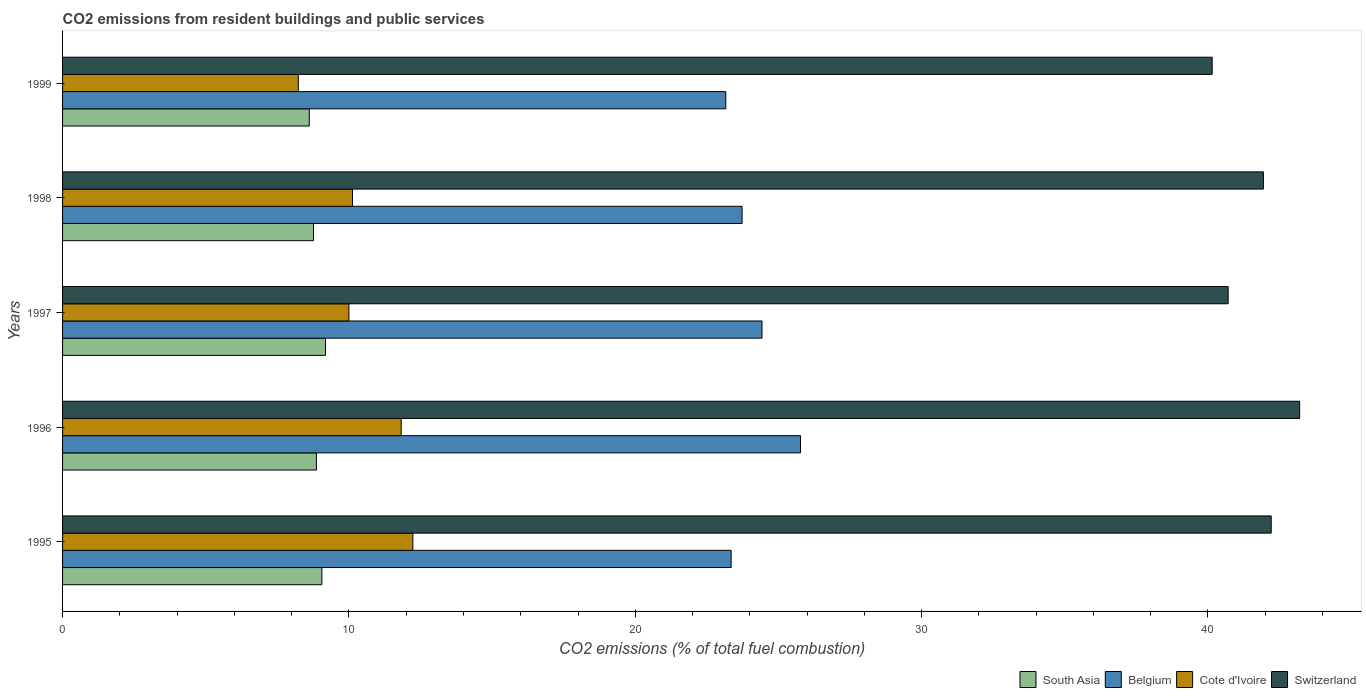How many different coloured bars are there?
Offer a terse response. 4. How many bars are there on the 1st tick from the bottom?
Your answer should be compact. 4. What is the label of the 2nd group of bars from the top?
Your answer should be very brief. 1998. In how many cases, is the number of bars for a given year not equal to the number of legend labels?
Give a very brief answer. 0. What is the total CO2 emitted in Cote d'Ivoire in 1995?
Your answer should be compact. 12.23. Across all years, what is the maximum total CO2 emitted in South Asia?
Your answer should be compact. 9.18. Across all years, what is the minimum total CO2 emitted in South Asia?
Ensure brevity in your answer.  8.62. In which year was the total CO2 emitted in Cote d'Ivoire maximum?
Offer a terse response. 1995. What is the total total CO2 emitted in Belgium in the graph?
Provide a succinct answer. 120.44. What is the difference between the total CO2 emitted in Switzerland in 1995 and that in 1997?
Your response must be concise. 1.5. What is the difference between the total CO2 emitted in South Asia in 1997 and the total CO2 emitted in Cote d'Ivoire in 1999?
Ensure brevity in your answer.  0.95. What is the average total CO2 emitted in Cote d'Ivoire per year?
Your answer should be compact. 10.48. In the year 1998, what is the difference between the total CO2 emitted in Switzerland and total CO2 emitted in Belgium?
Provide a short and direct response. 18.21. In how many years, is the total CO2 emitted in Switzerland greater than 38 ?
Ensure brevity in your answer.  5. What is the ratio of the total CO2 emitted in Switzerland in 1998 to that in 1999?
Your response must be concise. 1.04. Is the difference between the total CO2 emitted in Switzerland in 1998 and 1999 greater than the difference between the total CO2 emitted in Belgium in 1998 and 1999?
Offer a terse response. Yes. What is the difference between the highest and the second highest total CO2 emitted in Belgium?
Your answer should be compact. 1.35. What is the difference between the highest and the lowest total CO2 emitted in Switzerland?
Provide a succinct answer. 3.05. Is the sum of the total CO2 emitted in Switzerland in 1995 and 1999 greater than the maximum total CO2 emitted in Cote d'Ivoire across all years?
Your answer should be very brief. Yes. Is it the case that in every year, the sum of the total CO2 emitted in Belgium and total CO2 emitted in South Asia is greater than the sum of total CO2 emitted in Switzerland and total CO2 emitted in Cote d'Ivoire?
Give a very brief answer. No. What does the 1st bar from the bottom in 1998 represents?
Your response must be concise. South Asia. How many bars are there?
Offer a very short reply. 20. Are all the bars in the graph horizontal?
Give a very brief answer. Yes. How many legend labels are there?
Ensure brevity in your answer.  4. What is the title of the graph?
Keep it short and to the point. CO2 emissions from resident buildings and public services. Does "European Union" appear as one of the legend labels in the graph?
Make the answer very short. No. What is the label or title of the X-axis?
Keep it short and to the point. CO2 emissions (% of total fuel combustion). What is the label or title of the Y-axis?
Your answer should be very brief. Years. What is the CO2 emissions (% of total fuel combustion) of South Asia in 1995?
Your response must be concise. 9.06. What is the CO2 emissions (% of total fuel combustion) in Belgium in 1995?
Make the answer very short. 23.35. What is the CO2 emissions (% of total fuel combustion) of Cote d'Ivoire in 1995?
Your answer should be compact. 12.23. What is the CO2 emissions (% of total fuel combustion) of Switzerland in 1995?
Your answer should be very brief. 42.21. What is the CO2 emissions (% of total fuel combustion) in South Asia in 1996?
Keep it short and to the point. 8.86. What is the CO2 emissions (% of total fuel combustion) in Belgium in 1996?
Provide a short and direct response. 25.77. What is the CO2 emissions (% of total fuel combustion) of Cote d'Ivoire in 1996?
Your answer should be compact. 11.83. What is the CO2 emissions (% of total fuel combustion) of Switzerland in 1996?
Your response must be concise. 43.2. What is the CO2 emissions (% of total fuel combustion) of South Asia in 1997?
Offer a terse response. 9.18. What is the CO2 emissions (% of total fuel combustion) of Belgium in 1997?
Provide a succinct answer. 24.43. What is the CO2 emissions (% of total fuel combustion) of Cote d'Ivoire in 1997?
Your response must be concise. 10. What is the CO2 emissions (% of total fuel combustion) in Switzerland in 1997?
Provide a short and direct response. 40.7. What is the CO2 emissions (% of total fuel combustion) of South Asia in 1998?
Make the answer very short. 8.76. What is the CO2 emissions (% of total fuel combustion) in Belgium in 1998?
Provide a short and direct response. 23.73. What is the CO2 emissions (% of total fuel combustion) of Cote d'Ivoire in 1998?
Your answer should be compact. 10.12. What is the CO2 emissions (% of total fuel combustion) in Switzerland in 1998?
Your answer should be very brief. 41.94. What is the CO2 emissions (% of total fuel combustion) of South Asia in 1999?
Provide a short and direct response. 8.62. What is the CO2 emissions (% of total fuel combustion) in Belgium in 1999?
Offer a terse response. 23.16. What is the CO2 emissions (% of total fuel combustion) in Cote d'Ivoire in 1999?
Provide a succinct answer. 8.23. What is the CO2 emissions (% of total fuel combustion) of Switzerland in 1999?
Ensure brevity in your answer.  40.15. Across all years, what is the maximum CO2 emissions (% of total fuel combustion) of South Asia?
Ensure brevity in your answer.  9.18. Across all years, what is the maximum CO2 emissions (% of total fuel combustion) of Belgium?
Keep it short and to the point. 25.77. Across all years, what is the maximum CO2 emissions (% of total fuel combustion) of Cote d'Ivoire?
Make the answer very short. 12.23. Across all years, what is the maximum CO2 emissions (% of total fuel combustion) in Switzerland?
Your answer should be very brief. 43.2. Across all years, what is the minimum CO2 emissions (% of total fuel combustion) in South Asia?
Keep it short and to the point. 8.62. Across all years, what is the minimum CO2 emissions (% of total fuel combustion) of Belgium?
Provide a succinct answer. 23.16. Across all years, what is the minimum CO2 emissions (% of total fuel combustion) of Cote d'Ivoire?
Your answer should be very brief. 8.23. Across all years, what is the minimum CO2 emissions (% of total fuel combustion) of Switzerland?
Make the answer very short. 40.15. What is the total CO2 emissions (% of total fuel combustion) of South Asia in the graph?
Offer a terse response. 44.48. What is the total CO2 emissions (% of total fuel combustion) in Belgium in the graph?
Ensure brevity in your answer.  120.44. What is the total CO2 emissions (% of total fuel combustion) of Cote d'Ivoire in the graph?
Offer a very short reply. 52.42. What is the total CO2 emissions (% of total fuel combustion) of Switzerland in the graph?
Your answer should be compact. 208.2. What is the difference between the CO2 emissions (% of total fuel combustion) in South Asia in 1995 and that in 1996?
Offer a very short reply. 0.19. What is the difference between the CO2 emissions (% of total fuel combustion) of Belgium in 1995 and that in 1996?
Provide a succinct answer. -2.42. What is the difference between the CO2 emissions (% of total fuel combustion) in Cote d'Ivoire in 1995 and that in 1996?
Your answer should be very brief. 0.41. What is the difference between the CO2 emissions (% of total fuel combustion) of Switzerland in 1995 and that in 1996?
Your answer should be very brief. -0.99. What is the difference between the CO2 emissions (% of total fuel combustion) of South Asia in 1995 and that in 1997?
Provide a succinct answer. -0.13. What is the difference between the CO2 emissions (% of total fuel combustion) in Belgium in 1995 and that in 1997?
Ensure brevity in your answer.  -1.08. What is the difference between the CO2 emissions (% of total fuel combustion) of Cote d'Ivoire in 1995 and that in 1997?
Keep it short and to the point. 2.23. What is the difference between the CO2 emissions (% of total fuel combustion) of Switzerland in 1995 and that in 1997?
Ensure brevity in your answer.  1.5. What is the difference between the CO2 emissions (% of total fuel combustion) in South Asia in 1995 and that in 1998?
Your answer should be very brief. 0.29. What is the difference between the CO2 emissions (% of total fuel combustion) of Belgium in 1995 and that in 1998?
Your answer should be compact. -0.38. What is the difference between the CO2 emissions (% of total fuel combustion) of Cote d'Ivoire in 1995 and that in 1998?
Your response must be concise. 2.11. What is the difference between the CO2 emissions (% of total fuel combustion) of Switzerland in 1995 and that in 1998?
Your answer should be compact. 0.27. What is the difference between the CO2 emissions (% of total fuel combustion) in South Asia in 1995 and that in 1999?
Offer a very short reply. 0.44. What is the difference between the CO2 emissions (% of total fuel combustion) of Belgium in 1995 and that in 1999?
Your answer should be compact. 0.19. What is the difference between the CO2 emissions (% of total fuel combustion) of Cote d'Ivoire in 1995 and that in 1999?
Provide a succinct answer. 4. What is the difference between the CO2 emissions (% of total fuel combustion) in Switzerland in 1995 and that in 1999?
Your answer should be compact. 2.06. What is the difference between the CO2 emissions (% of total fuel combustion) of South Asia in 1996 and that in 1997?
Provide a short and direct response. -0.32. What is the difference between the CO2 emissions (% of total fuel combustion) in Belgium in 1996 and that in 1997?
Provide a succinct answer. 1.34. What is the difference between the CO2 emissions (% of total fuel combustion) of Cote d'Ivoire in 1996 and that in 1997?
Offer a terse response. 1.83. What is the difference between the CO2 emissions (% of total fuel combustion) of Switzerland in 1996 and that in 1997?
Your answer should be very brief. 2.5. What is the difference between the CO2 emissions (% of total fuel combustion) in South Asia in 1996 and that in 1998?
Provide a succinct answer. 0.1. What is the difference between the CO2 emissions (% of total fuel combustion) of Belgium in 1996 and that in 1998?
Make the answer very short. 2.04. What is the difference between the CO2 emissions (% of total fuel combustion) in Cote d'Ivoire in 1996 and that in 1998?
Offer a very short reply. 1.7. What is the difference between the CO2 emissions (% of total fuel combustion) of Switzerland in 1996 and that in 1998?
Your answer should be very brief. 1.27. What is the difference between the CO2 emissions (% of total fuel combustion) of South Asia in 1996 and that in 1999?
Ensure brevity in your answer.  0.25. What is the difference between the CO2 emissions (% of total fuel combustion) of Belgium in 1996 and that in 1999?
Provide a succinct answer. 2.61. What is the difference between the CO2 emissions (% of total fuel combustion) of Cote d'Ivoire in 1996 and that in 1999?
Your response must be concise. 3.59. What is the difference between the CO2 emissions (% of total fuel combustion) in Switzerland in 1996 and that in 1999?
Provide a succinct answer. 3.05. What is the difference between the CO2 emissions (% of total fuel combustion) in South Asia in 1997 and that in 1998?
Your answer should be very brief. 0.42. What is the difference between the CO2 emissions (% of total fuel combustion) in Belgium in 1997 and that in 1998?
Provide a succinct answer. 0.7. What is the difference between the CO2 emissions (% of total fuel combustion) in Cote d'Ivoire in 1997 and that in 1998?
Ensure brevity in your answer.  -0.12. What is the difference between the CO2 emissions (% of total fuel combustion) of Switzerland in 1997 and that in 1998?
Keep it short and to the point. -1.23. What is the difference between the CO2 emissions (% of total fuel combustion) in South Asia in 1997 and that in 1999?
Offer a very short reply. 0.57. What is the difference between the CO2 emissions (% of total fuel combustion) in Belgium in 1997 and that in 1999?
Offer a very short reply. 1.26. What is the difference between the CO2 emissions (% of total fuel combustion) in Cote d'Ivoire in 1997 and that in 1999?
Provide a short and direct response. 1.77. What is the difference between the CO2 emissions (% of total fuel combustion) in Switzerland in 1997 and that in 1999?
Offer a very short reply. 0.56. What is the difference between the CO2 emissions (% of total fuel combustion) in South Asia in 1998 and that in 1999?
Give a very brief answer. 0.15. What is the difference between the CO2 emissions (% of total fuel combustion) in Belgium in 1998 and that in 1999?
Your answer should be very brief. 0.57. What is the difference between the CO2 emissions (% of total fuel combustion) in Cote d'Ivoire in 1998 and that in 1999?
Ensure brevity in your answer.  1.89. What is the difference between the CO2 emissions (% of total fuel combustion) in Switzerland in 1998 and that in 1999?
Give a very brief answer. 1.79. What is the difference between the CO2 emissions (% of total fuel combustion) in South Asia in 1995 and the CO2 emissions (% of total fuel combustion) in Belgium in 1996?
Give a very brief answer. -16.72. What is the difference between the CO2 emissions (% of total fuel combustion) in South Asia in 1995 and the CO2 emissions (% of total fuel combustion) in Cote d'Ivoire in 1996?
Provide a short and direct response. -2.77. What is the difference between the CO2 emissions (% of total fuel combustion) in South Asia in 1995 and the CO2 emissions (% of total fuel combustion) in Switzerland in 1996?
Provide a short and direct response. -34.15. What is the difference between the CO2 emissions (% of total fuel combustion) in Belgium in 1995 and the CO2 emissions (% of total fuel combustion) in Cote d'Ivoire in 1996?
Make the answer very short. 11.52. What is the difference between the CO2 emissions (% of total fuel combustion) in Belgium in 1995 and the CO2 emissions (% of total fuel combustion) in Switzerland in 1996?
Your answer should be compact. -19.85. What is the difference between the CO2 emissions (% of total fuel combustion) in Cote d'Ivoire in 1995 and the CO2 emissions (% of total fuel combustion) in Switzerland in 1996?
Ensure brevity in your answer.  -30.97. What is the difference between the CO2 emissions (% of total fuel combustion) of South Asia in 1995 and the CO2 emissions (% of total fuel combustion) of Belgium in 1997?
Give a very brief answer. -15.37. What is the difference between the CO2 emissions (% of total fuel combustion) of South Asia in 1995 and the CO2 emissions (% of total fuel combustion) of Cote d'Ivoire in 1997?
Your answer should be very brief. -0.94. What is the difference between the CO2 emissions (% of total fuel combustion) in South Asia in 1995 and the CO2 emissions (% of total fuel combustion) in Switzerland in 1997?
Offer a very short reply. -31.65. What is the difference between the CO2 emissions (% of total fuel combustion) in Belgium in 1995 and the CO2 emissions (% of total fuel combustion) in Cote d'Ivoire in 1997?
Provide a short and direct response. 13.35. What is the difference between the CO2 emissions (% of total fuel combustion) of Belgium in 1995 and the CO2 emissions (% of total fuel combustion) of Switzerland in 1997?
Provide a succinct answer. -17.36. What is the difference between the CO2 emissions (% of total fuel combustion) of Cote d'Ivoire in 1995 and the CO2 emissions (% of total fuel combustion) of Switzerland in 1997?
Your answer should be very brief. -28.47. What is the difference between the CO2 emissions (% of total fuel combustion) of South Asia in 1995 and the CO2 emissions (% of total fuel combustion) of Belgium in 1998?
Offer a very short reply. -14.68. What is the difference between the CO2 emissions (% of total fuel combustion) of South Asia in 1995 and the CO2 emissions (% of total fuel combustion) of Cote d'Ivoire in 1998?
Offer a very short reply. -1.07. What is the difference between the CO2 emissions (% of total fuel combustion) in South Asia in 1995 and the CO2 emissions (% of total fuel combustion) in Switzerland in 1998?
Provide a succinct answer. -32.88. What is the difference between the CO2 emissions (% of total fuel combustion) in Belgium in 1995 and the CO2 emissions (% of total fuel combustion) in Cote d'Ivoire in 1998?
Ensure brevity in your answer.  13.22. What is the difference between the CO2 emissions (% of total fuel combustion) in Belgium in 1995 and the CO2 emissions (% of total fuel combustion) in Switzerland in 1998?
Your answer should be very brief. -18.59. What is the difference between the CO2 emissions (% of total fuel combustion) in Cote d'Ivoire in 1995 and the CO2 emissions (% of total fuel combustion) in Switzerland in 1998?
Offer a terse response. -29.7. What is the difference between the CO2 emissions (% of total fuel combustion) in South Asia in 1995 and the CO2 emissions (% of total fuel combustion) in Belgium in 1999?
Ensure brevity in your answer.  -14.11. What is the difference between the CO2 emissions (% of total fuel combustion) in South Asia in 1995 and the CO2 emissions (% of total fuel combustion) in Cote d'Ivoire in 1999?
Provide a succinct answer. 0.82. What is the difference between the CO2 emissions (% of total fuel combustion) in South Asia in 1995 and the CO2 emissions (% of total fuel combustion) in Switzerland in 1999?
Provide a succinct answer. -31.09. What is the difference between the CO2 emissions (% of total fuel combustion) of Belgium in 1995 and the CO2 emissions (% of total fuel combustion) of Cote d'Ivoire in 1999?
Offer a terse response. 15.12. What is the difference between the CO2 emissions (% of total fuel combustion) in Belgium in 1995 and the CO2 emissions (% of total fuel combustion) in Switzerland in 1999?
Offer a very short reply. -16.8. What is the difference between the CO2 emissions (% of total fuel combustion) of Cote d'Ivoire in 1995 and the CO2 emissions (% of total fuel combustion) of Switzerland in 1999?
Your answer should be very brief. -27.92. What is the difference between the CO2 emissions (% of total fuel combustion) of South Asia in 1996 and the CO2 emissions (% of total fuel combustion) of Belgium in 1997?
Give a very brief answer. -15.56. What is the difference between the CO2 emissions (% of total fuel combustion) of South Asia in 1996 and the CO2 emissions (% of total fuel combustion) of Cote d'Ivoire in 1997?
Make the answer very short. -1.14. What is the difference between the CO2 emissions (% of total fuel combustion) in South Asia in 1996 and the CO2 emissions (% of total fuel combustion) in Switzerland in 1997?
Make the answer very short. -31.84. What is the difference between the CO2 emissions (% of total fuel combustion) of Belgium in 1996 and the CO2 emissions (% of total fuel combustion) of Cote d'Ivoire in 1997?
Your response must be concise. 15.77. What is the difference between the CO2 emissions (% of total fuel combustion) of Belgium in 1996 and the CO2 emissions (% of total fuel combustion) of Switzerland in 1997?
Offer a terse response. -14.93. What is the difference between the CO2 emissions (% of total fuel combustion) of Cote d'Ivoire in 1996 and the CO2 emissions (% of total fuel combustion) of Switzerland in 1997?
Offer a very short reply. -28.88. What is the difference between the CO2 emissions (% of total fuel combustion) of South Asia in 1996 and the CO2 emissions (% of total fuel combustion) of Belgium in 1998?
Make the answer very short. -14.87. What is the difference between the CO2 emissions (% of total fuel combustion) of South Asia in 1996 and the CO2 emissions (% of total fuel combustion) of Cote d'Ivoire in 1998?
Ensure brevity in your answer.  -1.26. What is the difference between the CO2 emissions (% of total fuel combustion) in South Asia in 1996 and the CO2 emissions (% of total fuel combustion) in Switzerland in 1998?
Offer a terse response. -33.07. What is the difference between the CO2 emissions (% of total fuel combustion) of Belgium in 1996 and the CO2 emissions (% of total fuel combustion) of Cote d'Ivoire in 1998?
Keep it short and to the point. 15.65. What is the difference between the CO2 emissions (% of total fuel combustion) in Belgium in 1996 and the CO2 emissions (% of total fuel combustion) in Switzerland in 1998?
Provide a short and direct response. -16.17. What is the difference between the CO2 emissions (% of total fuel combustion) of Cote d'Ivoire in 1996 and the CO2 emissions (% of total fuel combustion) of Switzerland in 1998?
Provide a succinct answer. -30.11. What is the difference between the CO2 emissions (% of total fuel combustion) in South Asia in 1996 and the CO2 emissions (% of total fuel combustion) in Belgium in 1999?
Keep it short and to the point. -14.3. What is the difference between the CO2 emissions (% of total fuel combustion) of South Asia in 1996 and the CO2 emissions (% of total fuel combustion) of Cote d'Ivoire in 1999?
Provide a succinct answer. 0.63. What is the difference between the CO2 emissions (% of total fuel combustion) of South Asia in 1996 and the CO2 emissions (% of total fuel combustion) of Switzerland in 1999?
Your answer should be very brief. -31.28. What is the difference between the CO2 emissions (% of total fuel combustion) in Belgium in 1996 and the CO2 emissions (% of total fuel combustion) in Cote d'Ivoire in 1999?
Give a very brief answer. 17.54. What is the difference between the CO2 emissions (% of total fuel combustion) in Belgium in 1996 and the CO2 emissions (% of total fuel combustion) in Switzerland in 1999?
Your answer should be compact. -14.38. What is the difference between the CO2 emissions (% of total fuel combustion) in Cote d'Ivoire in 1996 and the CO2 emissions (% of total fuel combustion) in Switzerland in 1999?
Provide a short and direct response. -28.32. What is the difference between the CO2 emissions (% of total fuel combustion) of South Asia in 1997 and the CO2 emissions (% of total fuel combustion) of Belgium in 1998?
Ensure brevity in your answer.  -14.55. What is the difference between the CO2 emissions (% of total fuel combustion) of South Asia in 1997 and the CO2 emissions (% of total fuel combustion) of Cote d'Ivoire in 1998?
Your response must be concise. -0.94. What is the difference between the CO2 emissions (% of total fuel combustion) of South Asia in 1997 and the CO2 emissions (% of total fuel combustion) of Switzerland in 1998?
Provide a short and direct response. -32.75. What is the difference between the CO2 emissions (% of total fuel combustion) of Belgium in 1997 and the CO2 emissions (% of total fuel combustion) of Cote d'Ivoire in 1998?
Make the answer very short. 14.3. What is the difference between the CO2 emissions (% of total fuel combustion) in Belgium in 1997 and the CO2 emissions (% of total fuel combustion) in Switzerland in 1998?
Make the answer very short. -17.51. What is the difference between the CO2 emissions (% of total fuel combustion) of Cote d'Ivoire in 1997 and the CO2 emissions (% of total fuel combustion) of Switzerland in 1998?
Your answer should be compact. -31.94. What is the difference between the CO2 emissions (% of total fuel combustion) in South Asia in 1997 and the CO2 emissions (% of total fuel combustion) in Belgium in 1999?
Provide a short and direct response. -13.98. What is the difference between the CO2 emissions (% of total fuel combustion) in South Asia in 1997 and the CO2 emissions (% of total fuel combustion) in Cote d'Ivoire in 1999?
Your answer should be compact. 0.95. What is the difference between the CO2 emissions (% of total fuel combustion) in South Asia in 1997 and the CO2 emissions (% of total fuel combustion) in Switzerland in 1999?
Provide a short and direct response. -30.96. What is the difference between the CO2 emissions (% of total fuel combustion) in Belgium in 1997 and the CO2 emissions (% of total fuel combustion) in Cote d'Ivoire in 1999?
Ensure brevity in your answer.  16.19. What is the difference between the CO2 emissions (% of total fuel combustion) of Belgium in 1997 and the CO2 emissions (% of total fuel combustion) of Switzerland in 1999?
Provide a short and direct response. -15.72. What is the difference between the CO2 emissions (% of total fuel combustion) of Cote d'Ivoire in 1997 and the CO2 emissions (% of total fuel combustion) of Switzerland in 1999?
Your answer should be compact. -30.15. What is the difference between the CO2 emissions (% of total fuel combustion) of South Asia in 1998 and the CO2 emissions (% of total fuel combustion) of Belgium in 1999?
Your answer should be compact. -14.4. What is the difference between the CO2 emissions (% of total fuel combustion) of South Asia in 1998 and the CO2 emissions (% of total fuel combustion) of Cote d'Ivoire in 1999?
Your answer should be compact. 0.53. What is the difference between the CO2 emissions (% of total fuel combustion) in South Asia in 1998 and the CO2 emissions (% of total fuel combustion) in Switzerland in 1999?
Provide a succinct answer. -31.39. What is the difference between the CO2 emissions (% of total fuel combustion) of Belgium in 1998 and the CO2 emissions (% of total fuel combustion) of Cote d'Ivoire in 1999?
Offer a very short reply. 15.5. What is the difference between the CO2 emissions (% of total fuel combustion) in Belgium in 1998 and the CO2 emissions (% of total fuel combustion) in Switzerland in 1999?
Offer a terse response. -16.42. What is the difference between the CO2 emissions (% of total fuel combustion) of Cote d'Ivoire in 1998 and the CO2 emissions (% of total fuel combustion) of Switzerland in 1999?
Offer a terse response. -30.02. What is the average CO2 emissions (% of total fuel combustion) of South Asia per year?
Offer a very short reply. 8.9. What is the average CO2 emissions (% of total fuel combustion) in Belgium per year?
Give a very brief answer. 24.09. What is the average CO2 emissions (% of total fuel combustion) of Cote d'Ivoire per year?
Offer a terse response. 10.48. What is the average CO2 emissions (% of total fuel combustion) in Switzerland per year?
Keep it short and to the point. 41.64. In the year 1995, what is the difference between the CO2 emissions (% of total fuel combustion) in South Asia and CO2 emissions (% of total fuel combustion) in Belgium?
Provide a succinct answer. -14.29. In the year 1995, what is the difference between the CO2 emissions (% of total fuel combustion) of South Asia and CO2 emissions (% of total fuel combustion) of Cote d'Ivoire?
Give a very brief answer. -3.18. In the year 1995, what is the difference between the CO2 emissions (% of total fuel combustion) of South Asia and CO2 emissions (% of total fuel combustion) of Switzerland?
Your answer should be very brief. -33.15. In the year 1995, what is the difference between the CO2 emissions (% of total fuel combustion) of Belgium and CO2 emissions (% of total fuel combustion) of Cote d'Ivoire?
Offer a terse response. 11.12. In the year 1995, what is the difference between the CO2 emissions (% of total fuel combustion) of Belgium and CO2 emissions (% of total fuel combustion) of Switzerland?
Give a very brief answer. -18.86. In the year 1995, what is the difference between the CO2 emissions (% of total fuel combustion) in Cote d'Ivoire and CO2 emissions (% of total fuel combustion) in Switzerland?
Offer a very short reply. -29.98. In the year 1996, what is the difference between the CO2 emissions (% of total fuel combustion) in South Asia and CO2 emissions (% of total fuel combustion) in Belgium?
Your response must be concise. -16.91. In the year 1996, what is the difference between the CO2 emissions (% of total fuel combustion) in South Asia and CO2 emissions (% of total fuel combustion) in Cote d'Ivoire?
Offer a terse response. -2.96. In the year 1996, what is the difference between the CO2 emissions (% of total fuel combustion) in South Asia and CO2 emissions (% of total fuel combustion) in Switzerland?
Provide a short and direct response. -34.34. In the year 1996, what is the difference between the CO2 emissions (% of total fuel combustion) of Belgium and CO2 emissions (% of total fuel combustion) of Cote d'Ivoire?
Make the answer very short. 13.95. In the year 1996, what is the difference between the CO2 emissions (% of total fuel combustion) of Belgium and CO2 emissions (% of total fuel combustion) of Switzerland?
Keep it short and to the point. -17.43. In the year 1996, what is the difference between the CO2 emissions (% of total fuel combustion) in Cote d'Ivoire and CO2 emissions (% of total fuel combustion) in Switzerland?
Provide a short and direct response. -31.38. In the year 1997, what is the difference between the CO2 emissions (% of total fuel combustion) of South Asia and CO2 emissions (% of total fuel combustion) of Belgium?
Keep it short and to the point. -15.24. In the year 1997, what is the difference between the CO2 emissions (% of total fuel combustion) in South Asia and CO2 emissions (% of total fuel combustion) in Cote d'Ivoire?
Keep it short and to the point. -0.82. In the year 1997, what is the difference between the CO2 emissions (% of total fuel combustion) in South Asia and CO2 emissions (% of total fuel combustion) in Switzerland?
Keep it short and to the point. -31.52. In the year 1997, what is the difference between the CO2 emissions (% of total fuel combustion) of Belgium and CO2 emissions (% of total fuel combustion) of Cote d'Ivoire?
Your answer should be very brief. 14.43. In the year 1997, what is the difference between the CO2 emissions (% of total fuel combustion) of Belgium and CO2 emissions (% of total fuel combustion) of Switzerland?
Make the answer very short. -16.28. In the year 1997, what is the difference between the CO2 emissions (% of total fuel combustion) of Cote d'Ivoire and CO2 emissions (% of total fuel combustion) of Switzerland?
Keep it short and to the point. -30.7. In the year 1998, what is the difference between the CO2 emissions (% of total fuel combustion) of South Asia and CO2 emissions (% of total fuel combustion) of Belgium?
Your answer should be very brief. -14.97. In the year 1998, what is the difference between the CO2 emissions (% of total fuel combustion) in South Asia and CO2 emissions (% of total fuel combustion) in Cote d'Ivoire?
Your answer should be compact. -1.36. In the year 1998, what is the difference between the CO2 emissions (% of total fuel combustion) in South Asia and CO2 emissions (% of total fuel combustion) in Switzerland?
Provide a short and direct response. -33.17. In the year 1998, what is the difference between the CO2 emissions (% of total fuel combustion) in Belgium and CO2 emissions (% of total fuel combustion) in Cote d'Ivoire?
Offer a terse response. 13.61. In the year 1998, what is the difference between the CO2 emissions (% of total fuel combustion) in Belgium and CO2 emissions (% of total fuel combustion) in Switzerland?
Make the answer very short. -18.21. In the year 1998, what is the difference between the CO2 emissions (% of total fuel combustion) of Cote d'Ivoire and CO2 emissions (% of total fuel combustion) of Switzerland?
Your response must be concise. -31.81. In the year 1999, what is the difference between the CO2 emissions (% of total fuel combustion) of South Asia and CO2 emissions (% of total fuel combustion) of Belgium?
Your response must be concise. -14.55. In the year 1999, what is the difference between the CO2 emissions (% of total fuel combustion) of South Asia and CO2 emissions (% of total fuel combustion) of Cote d'Ivoire?
Offer a very short reply. 0.38. In the year 1999, what is the difference between the CO2 emissions (% of total fuel combustion) in South Asia and CO2 emissions (% of total fuel combustion) in Switzerland?
Your response must be concise. -31.53. In the year 1999, what is the difference between the CO2 emissions (% of total fuel combustion) in Belgium and CO2 emissions (% of total fuel combustion) in Cote d'Ivoire?
Provide a succinct answer. 14.93. In the year 1999, what is the difference between the CO2 emissions (% of total fuel combustion) in Belgium and CO2 emissions (% of total fuel combustion) in Switzerland?
Ensure brevity in your answer.  -16.99. In the year 1999, what is the difference between the CO2 emissions (% of total fuel combustion) in Cote d'Ivoire and CO2 emissions (% of total fuel combustion) in Switzerland?
Your answer should be compact. -31.91. What is the ratio of the CO2 emissions (% of total fuel combustion) in South Asia in 1995 to that in 1996?
Give a very brief answer. 1.02. What is the ratio of the CO2 emissions (% of total fuel combustion) of Belgium in 1995 to that in 1996?
Ensure brevity in your answer.  0.91. What is the ratio of the CO2 emissions (% of total fuel combustion) of Cote d'Ivoire in 1995 to that in 1996?
Ensure brevity in your answer.  1.03. What is the ratio of the CO2 emissions (% of total fuel combustion) of South Asia in 1995 to that in 1997?
Ensure brevity in your answer.  0.99. What is the ratio of the CO2 emissions (% of total fuel combustion) in Belgium in 1995 to that in 1997?
Your response must be concise. 0.96. What is the ratio of the CO2 emissions (% of total fuel combustion) in Cote d'Ivoire in 1995 to that in 1997?
Give a very brief answer. 1.22. What is the ratio of the CO2 emissions (% of total fuel combustion) of Switzerland in 1995 to that in 1997?
Your answer should be compact. 1.04. What is the ratio of the CO2 emissions (% of total fuel combustion) of South Asia in 1995 to that in 1998?
Your answer should be compact. 1.03. What is the ratio of the CO2 emissions (% of total fuel combustion) in Belgium in 1995 to that in 1998?
Give a very brief answer. 0.98. What is the ratio of the CO2 emissions (% of total fuel combustion) in Cote d'Ivoire in 1995 to that in 1998?
Provide a short and direct response. 1.21. What is the ratio of the CO2 emissions (% of total fuel combustion) in Switzerland in 1995 to that in 1998?
Provide a succinct answer. 1.01. What is the ratio of the CO2 emissions (% of total fuel combustion) of South Asia in 1995 to that in 1999?
Offer a terse response. 1.05. What is the ratio of the CO2 emissions (% of total fuel combustion) of Cote d'Ivoire in 1995 to that in 1999?
Offer a very short reply. 1.49. What is the ratio of the CO2 emissions (% of total fuel combustion) in Switzerland in 1995 to that in 1999?
Ensure brevity in your answer.  1.05. What is the ratio of the CO2 emissions (% of total fuel combustion) of South Asia in 1996 to that in 1997?
Your response must be concise. 0.97. What is the ratio of the CO2 emissions (% of total fuel combustion) of Belgium in 1996 to that in 1997?
Ensure brevity in your answer.  1.06. What is the ratio of the CO2 emissions (% of total fuel combustion) of Cote d'Ivoire in 1996 to that in 1997?
Ensure brevity in your answer.  1.18. What is the ratio of the CO2 emissions (% of total fuel combustion) of Switzerland in 1996 to that in 1997?
Offer a very short reply. 1.06. What is the ratio of the CO2 emissions (% of total fuel combustion) of South Asia in 1996 to that in 1998?
Your answer should be compact. 1.01. What is the ratio of the CO2 emissions (% of total fuel combustion) of Belgium in 1996 to that in 1998?
Your answer should be very brief. 1.09. What is the ratio of the CO2 emissions (% of total fuel combustion) of Cote d'Ivoire in 1996 to that in 1998?
Your response must be concise. 1.17. What is the ratio of the CO2 emissions (% of total fuel combustion) of Switzerland in 1996 to that in 1998?
Keep it short and to the point. 1.03. What is the ratio of the CO2 emissions (% of total fuel combustion) in South Asia in 1996 to that in 1999?
Offer a very short reply. 1.03. What is the ratio of the CO2 emissions (% of total fuel combustion) of Belgium in 1996 to that in 1999?
Provide a short and direct response. 1.11. What is the ratio of the CO2 emissions (% of total fuel combustion) of Cote d'Ivoire in 1996 to that in 1999?
Give a very brief answer. 1.44. What is the ratio of the CO2 emissions (% of total fuel combustion) of Switzerland in 1996 to that in 1999?
Make the answer very short. 1.08. What is the ratio of the CO2 emissions (% of total fuel combustion) of South Asia in 1997 to that in 1998?
Provide a short and direct response. 1.05. What is the ratio of the CO2 emissions (% of total fuel combustion) of Belgium in 1997 to that in 1998?
Make the answer very short. 1.03. What is the ratio of the CO2 emissions (% of total fuel combustion) in Switzerland in 1997 to that in 1998?
Offer a very short reply. 0.97. What is the ratio of the CO2 emissions (% of total fuel combustion) of South Asia in 1997 to that in 1999?
Your answer should be compact. 1.07. What is the ratio of the CO2 emissions (% of total fuel combustion) in Belgium in 1997 to that in 1999?
Make the answer very short. 1.05. What is the ratio of the CO2 emissions (% of total fuel combustion) in Cote d'Ivoire in 1997 to that in 1999?
Provide a short and direct response. 1.21. What is the ratio of the CO2 emissions (% of total fuel combustion) in Switzerland in 1997 to that in 1999?
Offer a very short reply. 1.01. What is the ratio of the CO2 emissions (% of total fuel combustion) in South Asia in 1998 to that in 1999?
Your answer should be very brief. 1.02. What is the ratio of the CO2 emissions (% of total fuel combustion) of Belgium in 1998 to that in 1999?
Give a very brief answer. 1.02. What is the ratio of the CO2 emissions (% of total fuel combustion) of Cote d'Ivoire in 1998 to that in 1999?
Ensure brevity in your answer.  1.23. What is the ratio of the CO2 emissions (% of total fuel combustion) in Switzerland in 1998 to that in 1999?
Your answer should be very brief. 1.04. What is the difference between the highest and the second highest CO2 emissions (% of total fuel combustion) in South Asia?
Offer a very short reply. 0.13. What is the difference between the highest and the second highest CO2 emissions (% of total fuel combustion) in Belgium?
Your answer should be very brief. 1.34. What is the difference between the highest and the second highest CO2 emissions (% of total fuel combustion) in Cote d'Ivoire?
Ensure brevity in your answer.  0.41. What is the difference between the highest and the second highest CO2 emissions (% of total fuel combustion) in Switzerland?
Keep it short and to the point. 0.99. What is the difference between the highest and the lowest CO2 emissions (% of total fuel combustion) in South Asia?
Provide a short and direct response. 0.57. What is the difference between the highest and the lowest CO2 emissions (% of total fuel combustion) of Belgium?
Your response must be concise. 2.61. What is the difference between the highest and the lowest CO2 emissions (% of total fuel combustion) of Cote d'Ivoire?
Provide a short and direct response. 4. What is the difference between the highest and the lowest CO2 emissions (% of total fuel combustion) in Switzerland?
Make the answer very short. 3.05. 